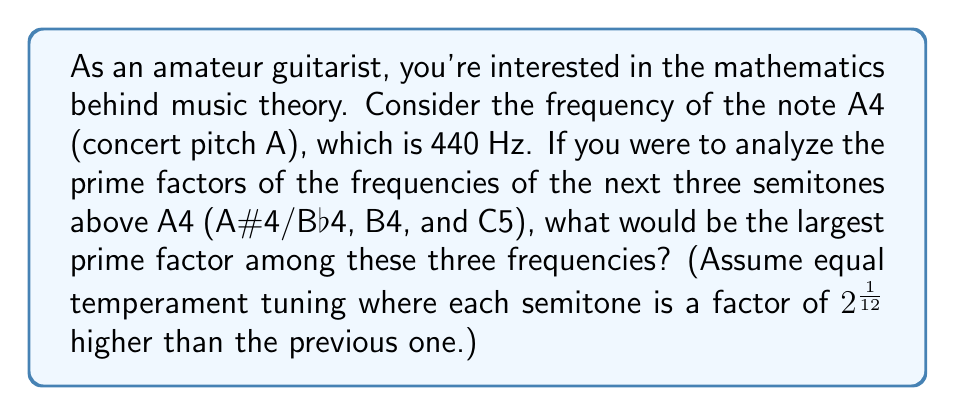What is the answer to this math problem? Let's approach this step-by-step:

1) In equal temperament tuning, each semitone is $2^{\frac{1}{12}}$ times the frequency of the previous note.

2) Given A4 = 440 Hz, we can calculate the frequencies of the next three semitones:

   A#4/Bb4 = $440 \times 2^{\frac{1}{12}} \approx 466.16$ Hz
   B4 = $440 \times 2^{\frac{2}{12}} \approx 493.88$ Hz
   C5 = $440 \times 2^{\frac{3}{12}} \approx 523.25$ Hz

3) Now, let's round these to the nearest whole number:

   A#4/Bb4 ≈ 466 Hz
   B4 ≈ 494 Hz
   C5 ≈ 523 Hz

4) Next, we need to find the prime factors of each:

   466 = 2 × 233
   494 = 2 × 13 × 19
   523 = 523 (prime)

5) The largest prime factors for each are:

   466: 233
   494: 19
   523: 523

6) Among these, the largest prime factor is 523.
Answer: The largest prime factor among the frequencies of A#4/Bb4, B4, and C5 is 523. 